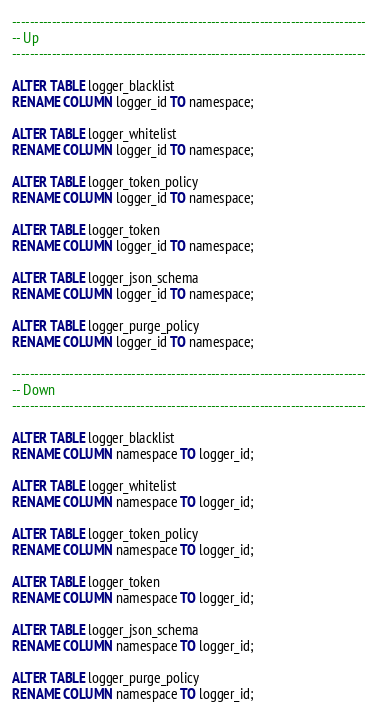Convert code to text. <code><loc_0><loc_0><loc_500><loc_500><_SQL_>--------------------------------------------------------------------------------
-- Up
--------------------------------------------------------------------------------

ALTER TABLE logger_blacklist
RENAME COLUMN logger_id TO namespace;

ALTER TABLE logger_whitelist
RENAME COLUMN logger_id TO namespace;

ALTER TABLE logger_token_policy
RENAME COLUMN logger_id TO namespace;

ALTER TABLE logger_token
RENAME COLUMN logger_id TO namespace;

ALTER TABLE logger_json_schema
RENAME COLUMN logger_id TO namespace;

ALTER TABLE logger_purge_policy
RENAME COLUMN logger_id TO namespace;

--------------------------------------------------------------------------------
-- Down
--------------------------------------------------------------------------------

ALTER TABLE logger_blacklist
RENAME COLUMN namespace TO logger_id;

ALTER TABLE logger_whitelist
RENAME COLUMN namespace TO logger_id;

ALTER TABLE logger_token_policy
RENAME COLUMN namespace TO logger_id;

ALTER TABLE logger_token
RENAME COLUMN namespace TO logger_id;

ALTER TABLE logger_json_schema
RENAME COLUMN namespace TO logger_id;

ALTER TABLE logger_purge_policy
RENAME COLUMN namespace TO logger_id;
</code> 